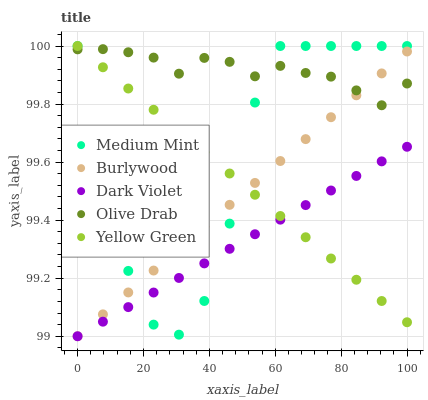Does Dark Violet have the minimum area under the curve?
Answer yes or no. Yes. Does Olive Drab have the maximum area under the curve?
Answer yes or no. Yes. Does Burlywood have the minimum area under the curve?
Answer yes or no. No. Does Burlywood have the maximum area under the curve?
Answer yes or no. No. Is Dark Violet the smoothest?
Answer yes or no. Yes. Is Medium Mint the roughest?
Answer yes or no. Yes. Is Burlywood the smoothest?
Answer yes or no. No. Is Burlywood the roughest?
Answer yes or no. No. Does Burlywood have the lowest value?
Answer yes or no. Yes. Does Olive Drab have the lowest value?
Answer yes or no. No. Does Yellow Green have the highest value?
Answer yes or no. Yes. Does Burlywood have the highest value?
Answer yes or no. No. Is Dark Violet less than Olive Drab?
Answer yes or no. Yes. Is Olive Drab greater than Dark Violet?
Answer yes or no. Yes. Does Burlywood intersect Medium Mint?
Answer yes or no. Yes. Is Burlywood less than Medium Mint?
Answer yes or no. No. Is Burlywood greater than Medium Mint?
Answer yes or no. No. Does Dark Violet intersect Olive Drab?
Answer yes or no. No. 